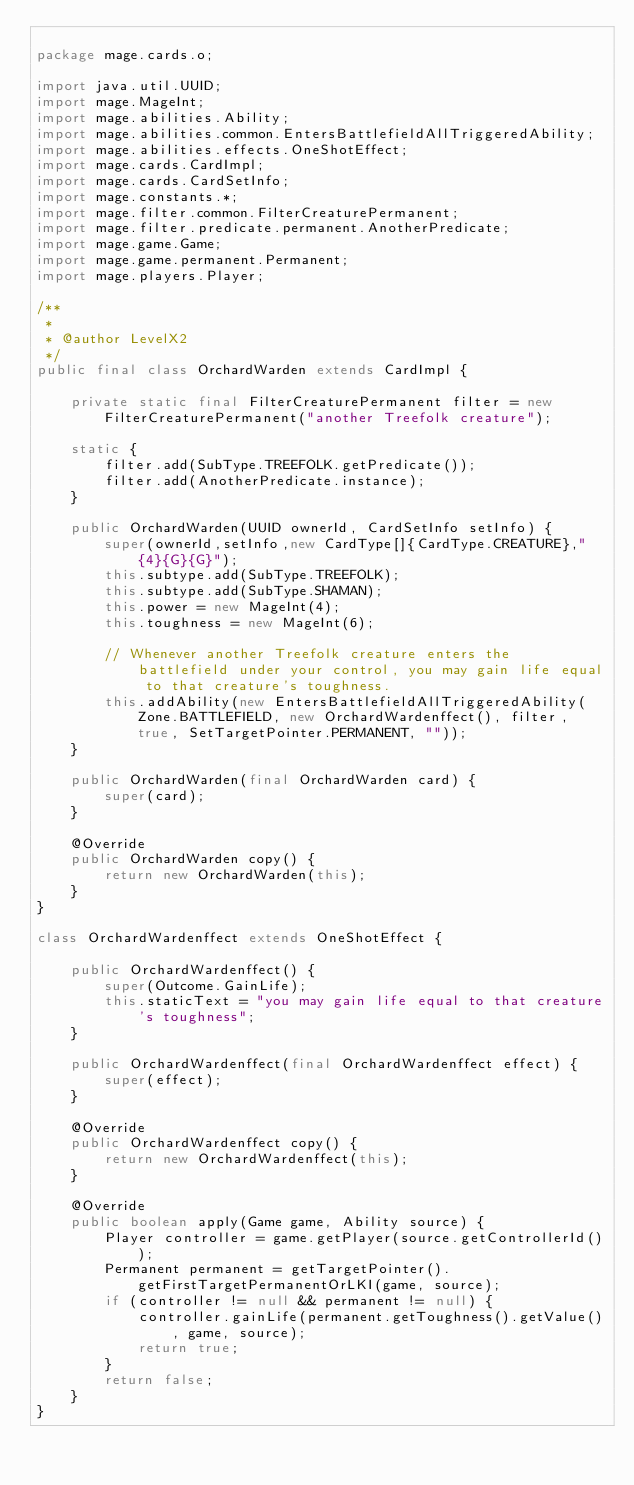<code> <loc_0><loc_0><loc_500><loc_500><_Java_>
package mage.cards.o;

import java.util.UUID;
import mage.MageInt;
import mage.abilities.Ability;
import mage.abilities.common.EntersBattlefieldAllTriggeredAbility;
import mage.abilities.effects.OneShotEffect;
import mage.cards.CardImpl;
import mage.cards.CardSetInfo;
import mage.constants.*;
import mage.filter.common.FilterCreaturePermanent;
import mage.filter.predicate.permanent.AnotherPredicate;
import mage.game.Game;
import mage.game.permanent.Permanent;
import mage.players.Player;

/**
 *
 * @author LevelX2
 */
public final class OrchardWarden extends CardImpl {

    private static final FilterCreaturePermanent filter = new FilterCreaturePermanent("another Treefolk creature");
    
    static {
        filter.add(SubType.TREEFOLK.getPredicate());
        filter.add(AnotherPredicate.instance);
    }
    
    public OrchardWarden(UUID ownerId, CardSetInfo setInfo) {
        super(ownerId,setInfo,new CardType[]{CardType.CREATURE},"{4}{G}{G}");
        this.subtype.add(SubType.TREEFOLK);
        this.subtype.add(SubType.SHAMAN);
        this.power = new MageInt(4);
        this.toughness = new MageInt(6);

        // Whenever another Treefolk creature enters the battlefield under your control, you may gain life equal to that creature's toughness.
        this.addAbility(new EntersBattlefieldAllTriggeredAbility(Zone.BATTLEFIELD, new OrchardWardenffect(), filter, true, SetTargetPointer.PERMANENT, ""));
    }

    public OrchardWarden(final OrchardWarden card) {
        super(card);
    }

    @Override
    public OrchardWarden copy() {
        return new OrchardWarden(this);
    }
}

class OrchardWardenffect extends OneShotEffect {
    
    public OrchardWardenffect() {
        super(Outcome.GainLife);
        this.staticText = "you may gain life equal to that creature's toughness";
    }
    
    public OrchardWardenffect(final OrchardWardenffect effect) {
        super(effect);
    }
    
    @Override
    public OrchardWardenffect copy() {
        return new OrchardWardenffect(this);
    }
    
    @Override
    public boolean apply(Game game, Ability source) {
        Player controller = game.getPlayer(source.getControllerId());
        Permanent permanent = getTargetPointer().getFirstTargetPermanentOrLKI(game, source);
        if (controller != null && permanent != null) {
            controller.gainLife(permanent.getToughness().getValue(), game, source);
            return true;
        }
        return false;
    }
}
</code> 